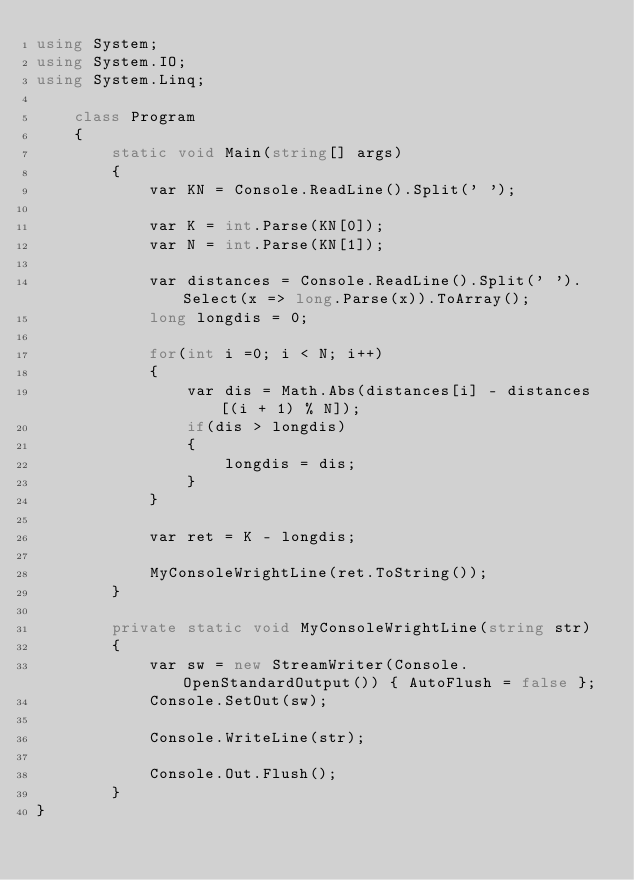<code> <loc_0><loc_0><loc_500><loc_500><_C#_>using System;
using System.IO;
using System.Linq;

    class Program
    {
        static void Main(string[] args)
        {
            var KN = Console.ReadLine().Split(' ');

            var K = int.Parse(KN[0]);
            var N = int.Parse(KN[1]);

            var distances = Console.ReadLine().Split(' ').Select(x => long.Parse(x)).ToArray();
            long longdis = 0;

            for(int i =0; i < N; i++)
            {
                var dis = Math.Abs(distances[i] - distances[(i + 1) % N]);
                if(dis > longdis)
                {
                    longdis = dis;
                }
            }

            var ret = K - longdis;

            MyConsoleWrightLine(ret.ToString());
        }

        private static void MyConsoleWrightLine(string str)
        {
            var sw = new StreamWriter(Console.OpenStandardOutput()) { AutoFlush = false };
            Console.SetOut(sw);

            Console.WriteLine(str);

            Console.Out.Flush();
        }
}
</code> 